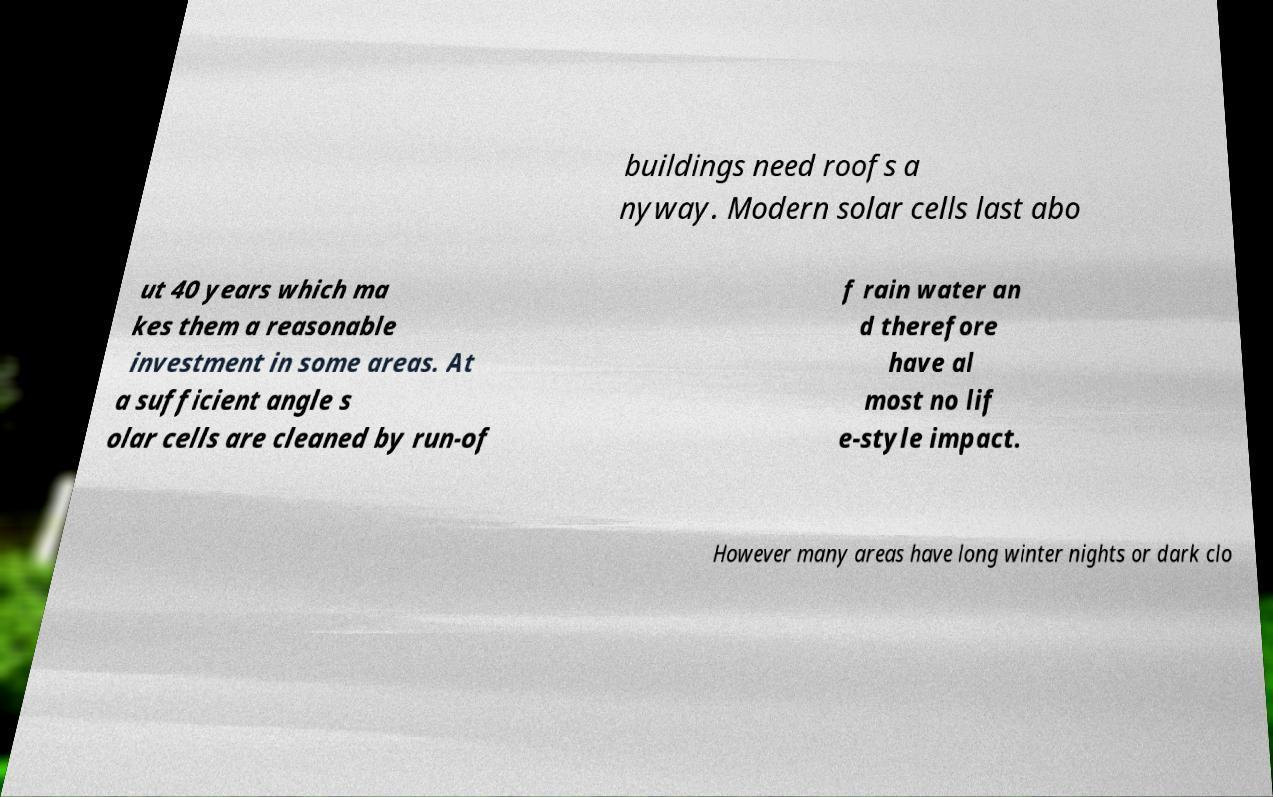Please identify and transcribe the text found in this image. buildings need roofs a nyway. Modern solar cells last abo ut 40 years which ma kes them a reasonable investment in some areas. At a sufficient angle s olar cells are cleaned by run-of f rain water an d therefore have al most no lif e-style impact. However many areas have long winter nights or dark clo 